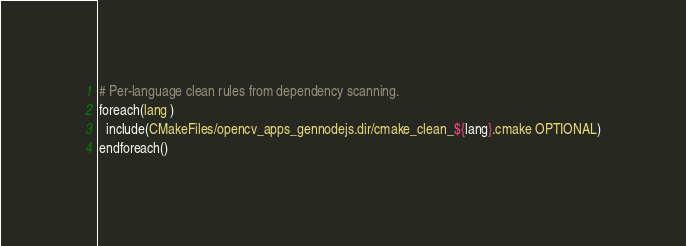<code> <loc_0><loc_0><loc_500><loc_500><_CMake_>
# Per-language clean rules from dependency scanning.
foreach(lang )
  include(CMakeFiles/opencv_apps_gennodejs.dir/cmake_clean_${lang}.cmake OPTIONAL)
endforeach()
</code> 